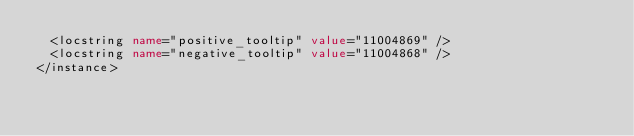Convert code to text. <code><loc_0><loc_0><loc_500><loc_500><_XML_>	<locstring name="positive_tooltip" value="11004869" />
	<locstring name="negative_tooltip" value="11004868" />
</instance></code> 